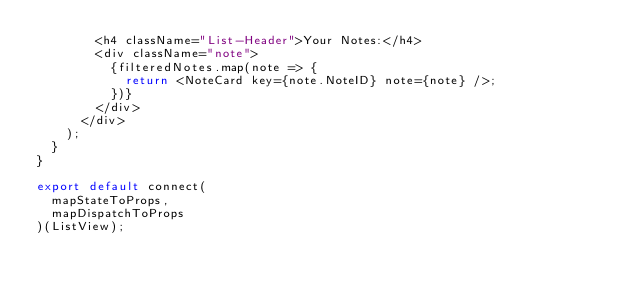<code> <loc_0><loc_0><loc_500><loc_500><_JavaScript_>        <h4 className="List-Header">Your Notes:</h4>
        <div className="note">
          {filteredNotes.map(note => {
            return <NoteCard key={note.NoteID} note={note} />;
          })}
        </div>
      </div>
    );
  }
}

export default connect(
  mapStateToProps,
  mapDispatchToProps
)(ListView);
</code> 